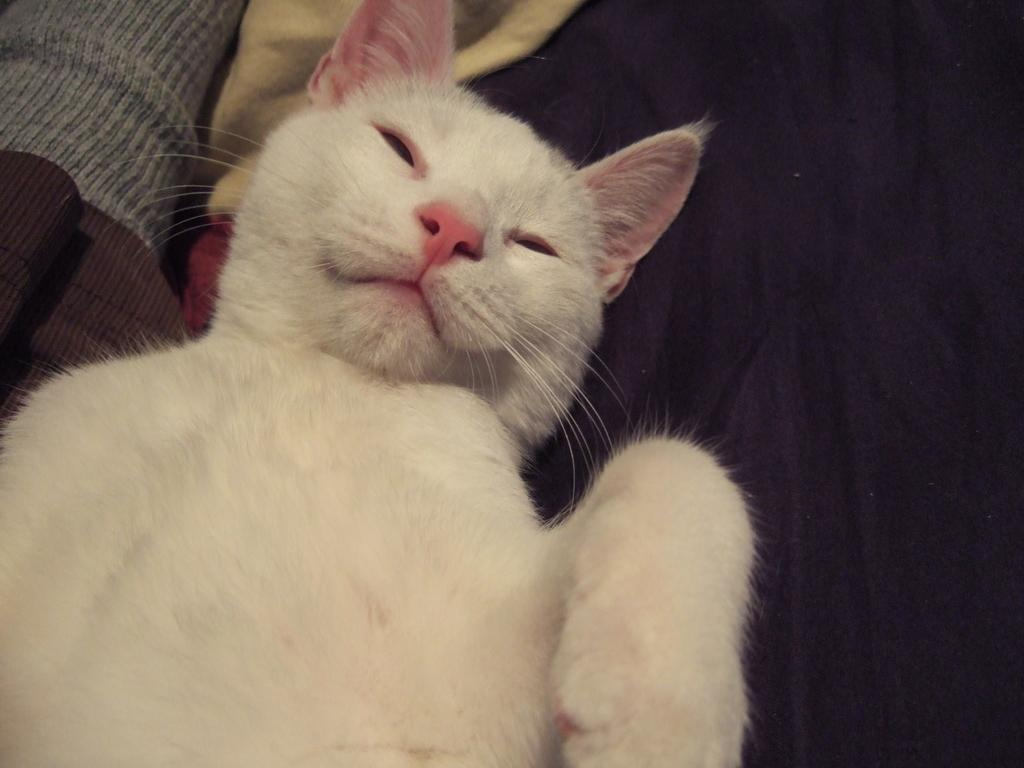What type of animal is in the image? There is a white color cat in the image. What can be seen in the background of the image? There are clothes and other objects visible in the background of the image. How many apples can be seen in the image? There are no apples present in the image. What discovery was made by the cat in the image? There is no indication of a discovery made by the cat in the image. 